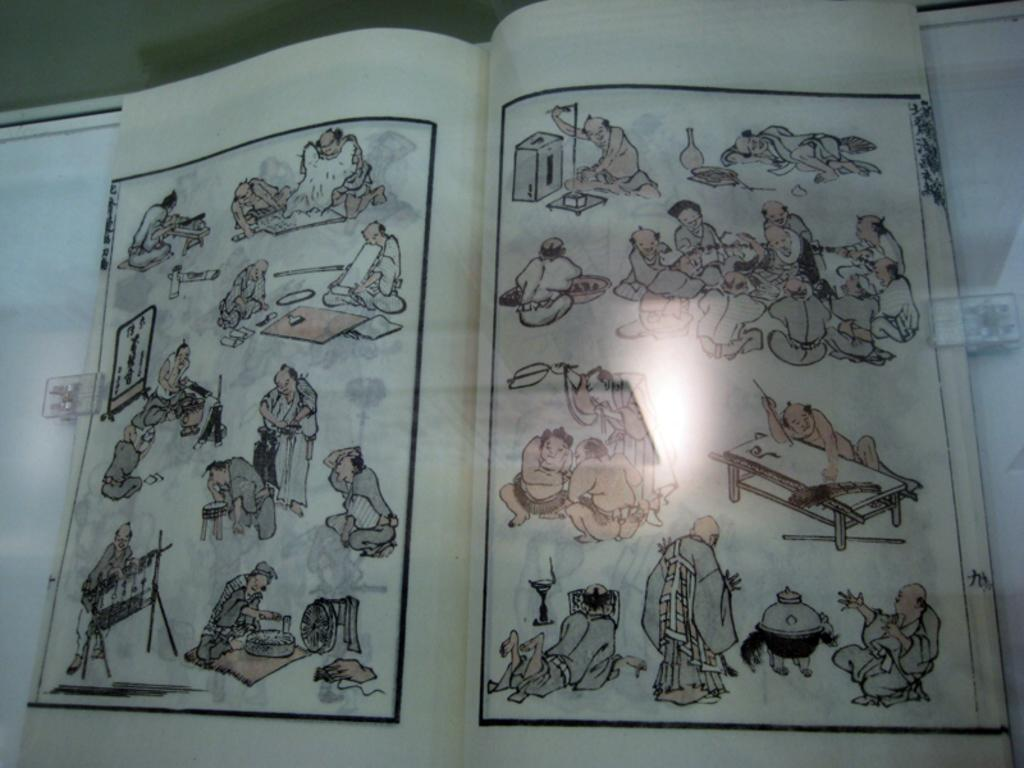What is depicted on the paper in the image? There is a sketch on a paper in the image. What types of subjects are included in the sketch? The sketch includes people and other objects. Is there a carriage in the sketch on the paper? There is no mention of a carriage in the provided facts, so we cannot determine if it is present in the sketch. 